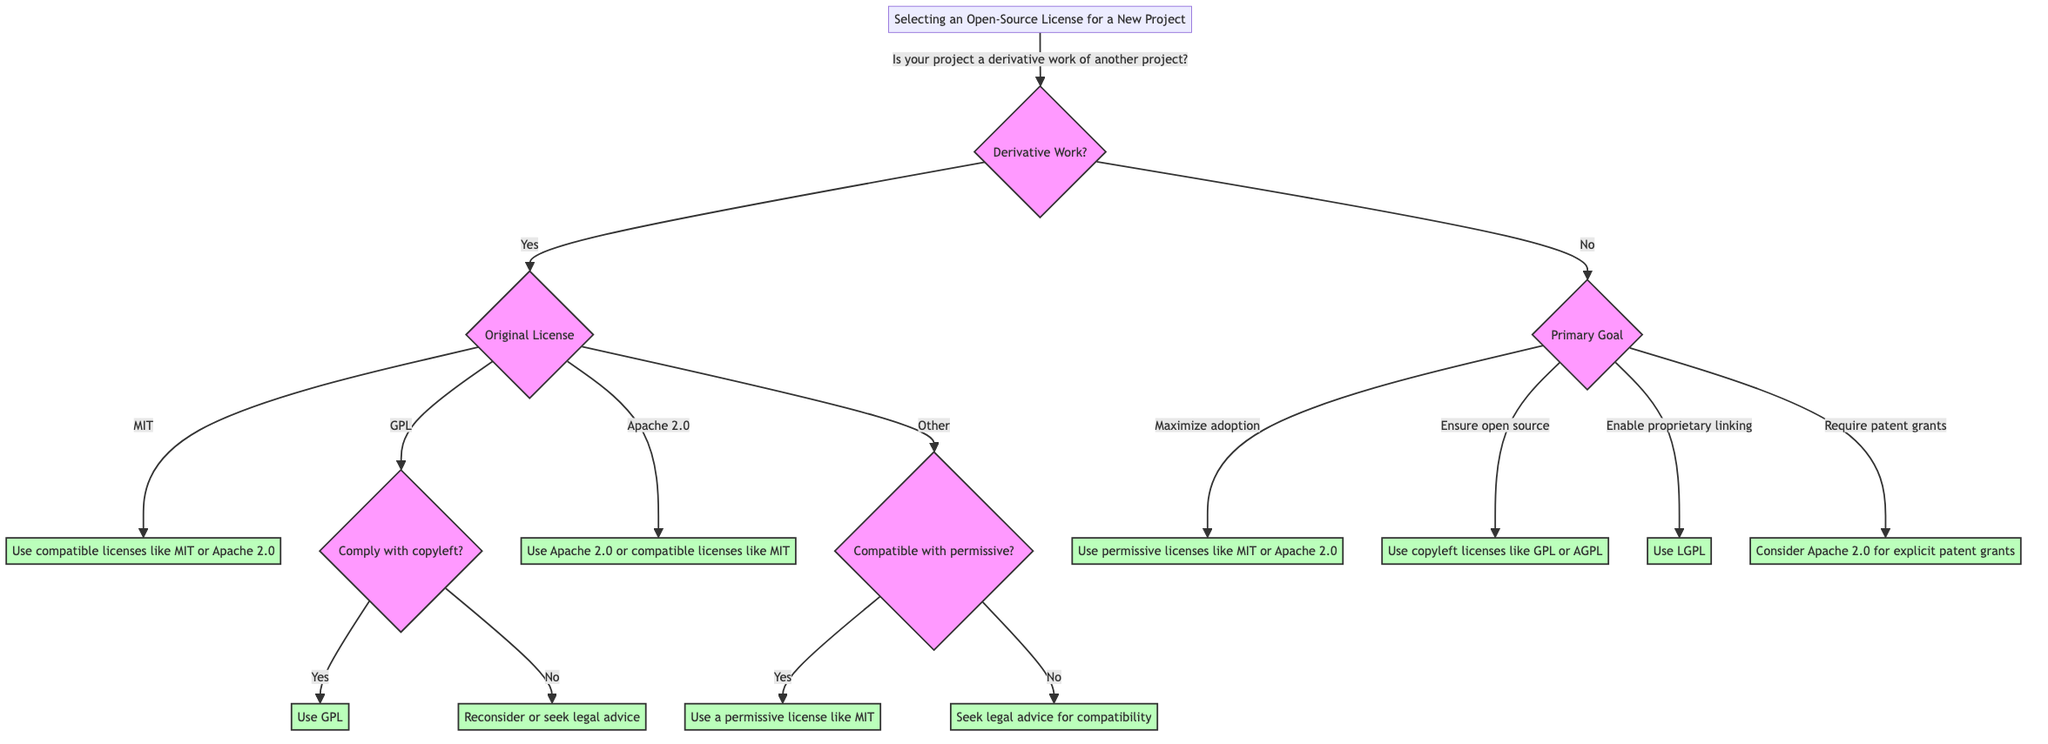Is your project a derivative work of another project? This is the first question in the decision tree, asking if the project is a derivative work. The answer will guide the next steps in the decision-making process regarding the license selection.
Answer: Yes What does the original project license as per the diagram? This question asks about the next step after confirming the project is a derivative work. The diagram specifies that understanding the original project's license is crucial for making an informed decision about the new license.
Answer: Original License If the original project is using GPL, what are the options for compliance with copyleft? The flow from the GPL license leads to a decision point about compliance with copyleft requirements. If yes, the recommendation is to use GPL; if no, it suggests reconsidering licensing or seeking legal advice.
Answer: Comply with copyleft? What should you do if your primary goal is to maximize adoption with minimal restrictions? Looking at the options under the primary goal section, if the goal is to maximize adoption with minimal restrictions, the recommendation is to use permissive licenses like MIT or Apache 2.0.
Answer: Use permissive licenses like MIT or Apache 2.0 If your project requires patent grants, which license should you consider? According to the decision tree, if a project requires explicit patent grants, the recommendation is to consider Apache 2.0 for its advantages in that area.
Answer: Consider Apache 2.0 for explicit patent grants What happens if the original project is under a license that is not compatible with permissive licenses? Referring to the decision point regarding other licenses, if the license is not compatible with permissive licenses, the recommendation is to seek legal advice for compatibility.
Answer: Seek legal advice for compatibility Which licensing option allows linking with proprietary code? In the diagram's "Primary Goal" section, the option for enabling linking with proprietary code is represented by using LGPL.
Answer: Use LGPL What is the relationship between the 'GPL' and 'Comply with copyleft?' nodes? The 'GPL' node leads to a decision node about copyleft compliance. Depending on whether the user wants to comply with copyleft, they would either use GPL or reconsider their licensing option.
Answer: Decision node for copyleft compliance What is the next step after confirming your project is a derivative work and is licensed under MIT? Following the confirmation under MIT, the diagram indicates that the next step would be to use compatible licenses like MIT or Apache 2.0.
Answer: Use compatible licenses like MIT or Apache 2.0 